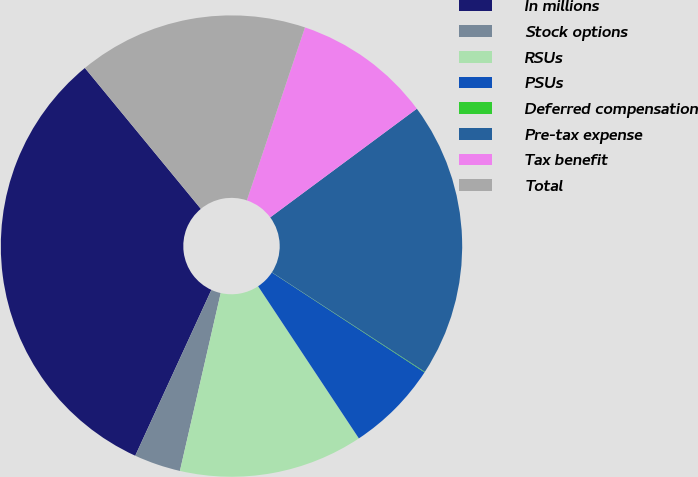Convert chart to OTSL. <chart><loc_0><loc_0><loc_500><loc_500><pie_chart><fcel>In millions<fcel>Stock options<fcel>RSUs<fcel>PSUs<fcel>Deferred compensation<fcel>Pre-tax expense<fcel>Tax benefit<fcel>Total<nl><fcel>32.19%<fcel>3.26%<fcel>12.9%<fcel>6.47%<fcel>0.04%<fcel>19.33%<fcel>9.69%<fcel>16.12%<nl></chart> 